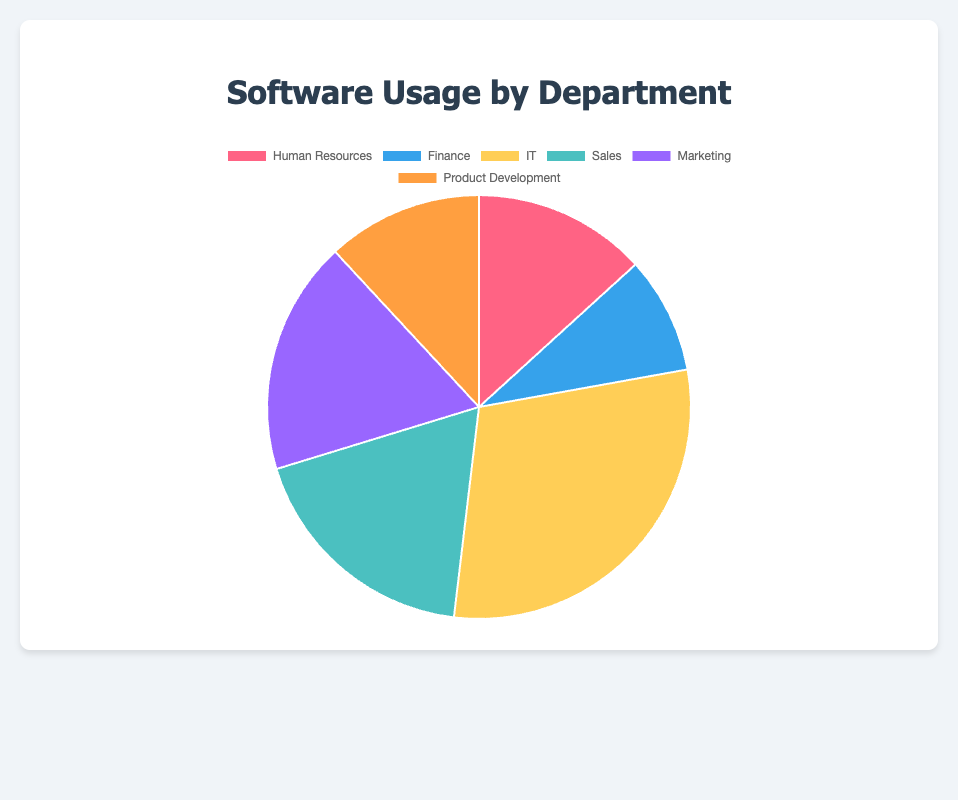What's the total usage count for the IT department? The IT department's total usage is calculated by summing the usage counts for Windows (300), VMware (150), and McAfee (100). So, 300 + 150 + 100 = 550
Answer: 550 Which department uses the most software? The department with the highest slice in the pie chart represents the one with the most software usage. The IT department has the largest slice with a total usage count of 550
Answer: IT How does the software usage in Marketing compare to Finance? The total usage counts for Marketing and Finance departments need to be compared. Marketing's usage is 80 + 150 + 100 = 330, while Finance's is 90 + 45 + 30 = 165. 330 is greater than 165
Answer: Marketing has more software usage than Finance What's the difference in software usage between Sales and Product Development? The total usage count for Sales is 180 + 60 + 100 = 340, and for Product Development it is 70 + 90 + 60 = 220. The difference is 340 - 220 = 120
Answer: 120 Which department has a greater usage count, Human Resources or Marketing? Human Resources' total usage is 120 + 75 + 50 = 245. Marketing's total usage is 80 + 150 + 100 = 330. Therefore, Marketing has a greater usage count
Answer: Marketing If we combine the usage counts for IT and Sales, what percentage of the total usage do they represent? The combined usage for IT and Sales is 550 + 340 = 890. The total usage for all departments should be summed up: 245 + 165 + 550 + 340 + 330 + 220 = 1850. The percentage is (890 / 1850) * 100 ≈ 48.11%
Answer: 48.11% What is the average software usage count across all departments? The average is found by dividing the total usage count by the number of departments. The total is 1850 and there are 6 departments, so 1850 / 6 ≈ 308.33
Answer: 308.33 Which department has the smallest usage count for its software? By comparing the slices in the pie chart, Product Development has the smallest total usage count with 220
Answer: Product Development 